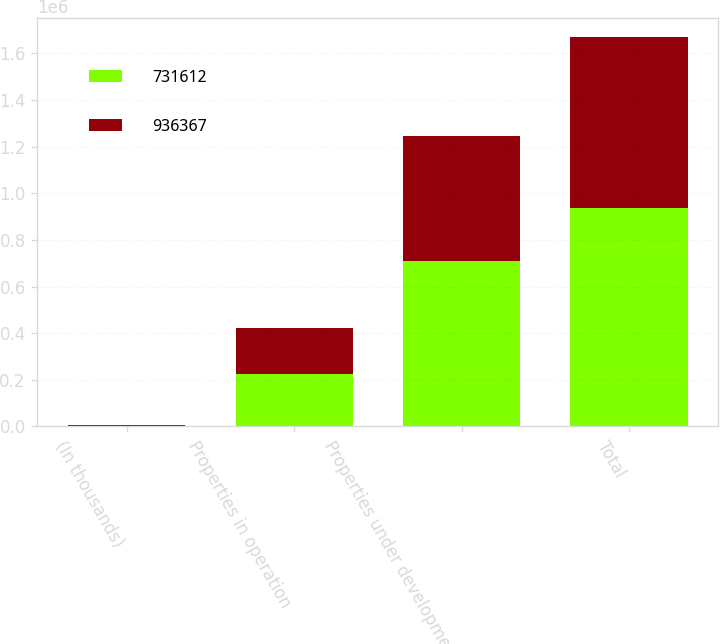<chart> <loc_0><loc_0><loc_500><loc_500><stacked_bar_chart><ecel><fcel>(In thousands)<fcel>Properties in operation<fcel>Properties under development<fcel>Total<nl><fcel>731612<fcel>2015<fcel>226055<fcel>710312<fcel>936367<nl><fcel>936367<fcel>2014<fcel>196980<fcel>534632<fcel>731612<nl></chart> 